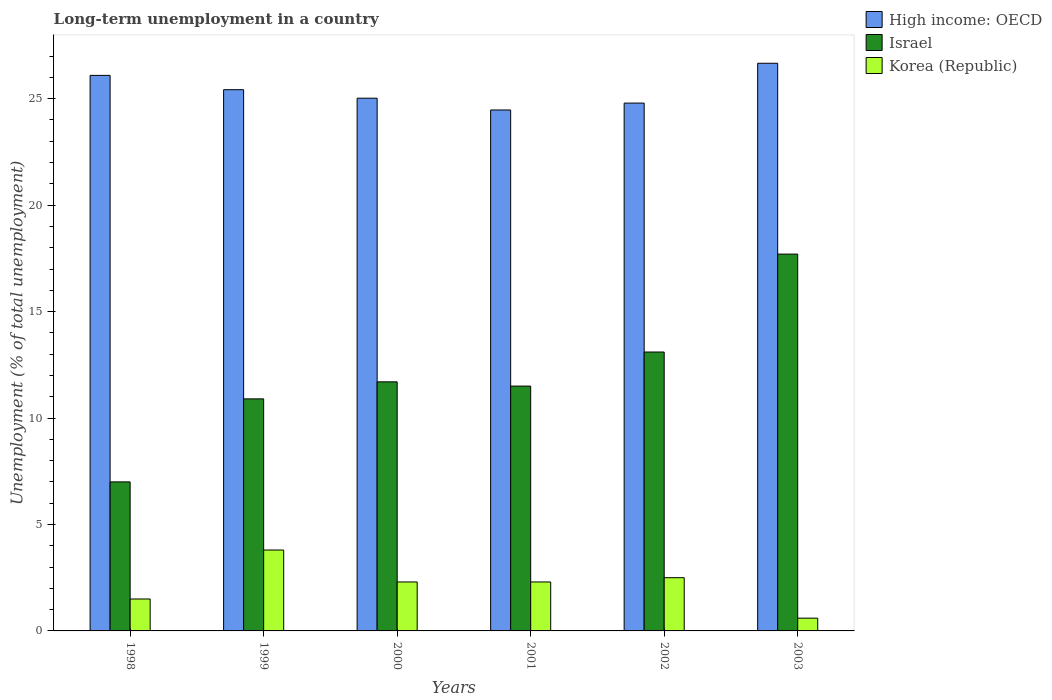How many different coloured bars are there?
Make the answer very short. 3. Are the number of bars on each tick of the X-axis equal?
Offer a terse response. Yes. How many bars are there on the 2nd tick from the left?
Offer a very short reply. 3. How many bars are there on the 6th tick from the right?
Give a very brief answer. 3. What is the label of the 2nd group of bars from the left?
Provide a succinct answer. 1999. In how many cases, is the number of bars for a given year not equal to the number of legend labels?
Make the answer very short. 0. What is the percentage of long-term unemployed population in Israel in 2000?
Ensure brevity in your answer.  11.7. Across all years, what is the maximum percentage of long-term unemployed population in Israel?
Your answer should be compact. 17.7. Across all years, what is the minimum percentage of long-term unemployed population in High income: OECD?
Offer a terse response. 24.47. In which year was the percentage of long-term unemployed population in Israel maximum?
Keep it short and to the point. 2003. In which year was the percentage of long-term unemployed population in Israel minimum?
Keep it short and to the point. 1998. What is the total percentage of long-term unemployed population in High income: OECD in the graph?
Keep it short and to the point. 152.47. What is the difference between the percentage of long-term unemployed population in High income: OECD in 1999 and that in 2000?
Offer a very short reply. 0.4. What is the difference between the percentage of long-term unemployed population in High income: OECD in 1998 and the percentage of long-term unemployed population in Korea (Republic) in 2001?
Give a very brief answer. 23.79. What is the average percentage of long-term unemployed population in Israel per year?
Offer a very short reply. 11.98. In the year 2002, what is the difference between the percentage of long-term unemployed population in Korea (Republic) and percentage of long-term unemployed population in High income: OECD?
Your answer should be very brief. -22.29. What is the ratio of the percentage of long-term unemployed population in Korea (Republic) in 1999 to that in 2003?
Your response must be concise. 6.33. Is the percentage of long-term unemployed population in Israel in 1998 less than that in 2000?
Give a very brief answer. Yes. What is the difference between the highest and the second highest percentage of long-term unemployed population in High income: OECD?
Your answer should be very brief. 0.57. What is the difference between the highest and the lowest percentage of long-term unemployed population in Korea (Republic)?
Give a very brief answer. 3.2. In how many years, is the percentage of long-term unemployed population in Korea (Republic) greater than the average percentage of long-term unemployed population in Korea (Republic) taken over all years?
Offer a very short reply. 4. What does the 2nd bar from the left in 2002 represents?
Offer a very short reply. Israel. What does the 3rd bar from the right in 2003 represents?
Keep it short and to the point. High income: OECD. How many bars are there?
Give a very brief answer. 18. Are all the bars in the graph horizontal?
Ensure brevity in your answer.  No. What is the difference between two consecutive major ticks on the Y-axis?
Make the answer very short. 5. Does the graph contain any zero values?
Your answer should be compact. No. Where does the legend appear in the graph?
Your answer should be very brief. Top right. How many legend labels are there?
Provide a succinct answer. 3. What is the title of the graph?
Keep it short and to the point. Long-term unemployment in a country. Does "Germany" appear as one of the legend labels in the graph?
Your answer should be compact. No. What is the label or title of the Y-axis?
Give a very brief answer. Unemployment (% of total unemployment). What is the Unemployment (% of total unemployment) of High income: OECD in 1998?
Give a very brief answer. 26.09. What is the Unemployment (% of total unemployment) in High income: OECD in 1999?
Ensure brevity in your answer.  25.42. What is the Unemployment (% of total unemployment) in Israel in 1999?
Offer a very short reply. 10.9. What is the Unemployment (% of total unemployment) in Korea (Republic) in 1999?
Make the answer very short. 3.8. What is the Unemployment (% of total unemployment) of High income: OECD in 2000?
Offer a terse response. 25.02. What is the Unemployment (% of total unemployment) of Israel in 2000?
Your answer should be compact. 11.7. What is the Unemployment (% of total unemployment) in Korea (Republic) in 2000?
Provide a succinct answer. 2.3. What is the Unemployment (% of total unemployment) of High income: OECD in 2001?
Keep it short and to the point. 24.47. What is the Unemployment (% of total unemployment) in Korea (Republic) in 2001?
Keep it short and to the point. 2.3. What is the Unemployment (% of total unemployment) in High income: OECD in 2002?
Offer a terse response. 24.79. What is the Unemployment (% of total unemployment) of Israel in 2002?
Your response must be concise. 13.1. What is the Unemployment (% of total unemployment) of Korea (Republic) in 2002?
Provide a succinct answer. 2.5. What is the Unemployment (% of total unemployment) of High income: OECD in 2003?
Your answer should be very brief. 26.66. What is the Unemployment (% of total unemployment) of Israel in 2003?
Provide a succinct answer. 17.7. What is the Unemployment (% of total unemployment) in Korea (Republic) in 2003?
Ensure brevity in your answer.  0.6. Across all years, what is the maximum Unemployment (% of total unemployment) of High income: OECD?
Your answer should be compact. 26.66. Across all years, what is the maximum Unemployment (% of total unemployment) of Israel?
Provide a succinct answer. 17.7. Across all years, what is the maximum Unemployment (% of total unemployment) in Korea (Republic)?
Make the answer very short. 3.8. Across all years, what is the minimum Unemployment (% of total unemployment) of High income: OECD?
Provide a short and direct response. 24.47. Across all years, what is the minimum Unemployment (% of total unemployment) in Israel?
Make the answer very short. 7. Across all years, what is the minimum Unemployment (% of total unemployment) in Korea (Republic)?
Your answer should be compact. 0.6. What is the total Unemployment (% of total unemployment) of High income: OECD in the graph?
Give a very brief answer. 152.47. What is the total Unemployment (% of total unemployment) in Israel in the graph?
Provide a succinct answer. 71.9. What is the total Unemployment (% of total unemployment) in Korea (Republic) in the graph?
Make the answer very short. 13. What is the difference between the Unemployment (% of total unemployment) in High income: OECD in 1998 and that in 1999?
Keep it short and to the point. 0.67. What is the difference between the Unemployment (% of total unemployment) in Israel in 1998 and that in 1999?
Provide a short and direct response. -3.9. What is the difference between the Unemployment (% of total unemployment) of Korea (Republic) in 1998 and that in 1999?
Offer a very short reply. -2.3. What is the difference between the Unemployment (% of total unemployment) in High income: OECD in 1998 and that in 2000?
Provide a short and direct response. 1.07. What is the difference between the Unemployment (% of total unemployment) of Korea (Republic) in 1998 and that in 2000?
Provide a succinct answer. -0.8. What is the difference between the Unemployment (% of total unemployment) in High income: OECD in 1998 and that in 2001?
Offer a very short reply. 1.63. What is the difference between the Unemployment (% of total unemployment) of Israel in 1998 and that in 2001?
Offer a terse response. -4.5. What is the difference between the Unemployment (% of total unemployment) of Korea (Republic) in 1998 and that in 2001?
Keep it short and to the point. -0.8. What is the difference between the Unemployment (% of total unemployment) of High income: OECD in 1998 and that in 2002?
Your answer should be compact. 1.3. What is the difference between the Unemployment (% of total unemployment) of Korea (Republic) in 1998 and that in 2002?
Give a very brief answer. -1. What is the difference between the Unemployment (% of total unemployment) of High income: OECD in 1998 and that in 2003?
Your answer should be compact. -0.57. What is the difference between the Unemployment (% of total unemployment) in High income: OECD in 1999 and that in 2000?
Your answer should be compact. 0.4. What is the difference between the Unemployment (% of total unemployment) of Korea (Republic) in 1999 and that in 2000?
Provide a succinct answer. 1.5. What is the difference between the Unemployment (% of total unemployment) of High income: OECD in 1999 and that in 2001?
Give a very brief answer. 0.95. What is the difference between the Unemployment (% of total unemployment) in Israel in 1999 and that in 2001?
Provide a short and direct response. -0.6. What is the difference between the Unemployment (% of total unemployment) of High income: OECD in 1999 and that in 2002?
Your answer should be compact. 0.63. What is the difference between the Unemployment (% of total unemployment) of High income: OECD in 1999 and that in 2003?
Your answer should be very brief. -1.24. What is the difference between the Unemployment (% of total unemployment) of Israel in 1999 and that in 2003?
Your answer should be compact. -6.8. What is the difference between the Unemployment (% of total unemployment) in Korea (Republic) in 1999 and that in 2003?
Your response must be concise. 3.2. What is the difference between the Unemployment (% of total unemployment) in High income: OECD in 2000 and that in 2001?
Provide a short and direct response. 0.55. What is the difference between the Unemployment (% of total unemployment) in Israel in 2000 and that in 2001?
Provide a short and direct response. 0.2. What is the difference between the Unemployment (% of total unemployment) of High income: OECD in 2000 and that in 2002?
Your answer should be compact. 0.23. What is the difference between the Unemployment (% of total unemployment) of Korea (Republic) in 2000 and that in 2002?
Keep it short and to the point. -0.2. What is the difference between the Unemployment (% of total unemployment) of High income: OECD in 2000 and that in 2003?
Your response must be concise. -1.64. What is the difference between the Unemployment (% of total unemployment) in High income: OECD in 2001 and that in 2002?
Your response must be concise. -0.32. What is the difference between the Unemployment (% of total unemployment) in Korea (Republic) in 2001 and that in 2002?
Provide a succinct answer. -0.2. What is the difference between the Unemployment (% of total unemployment) in High income: OECD in 2001 and that in 2003?
Ensure brevity in your answer.  -2.19. What is the difference between the Unemployment (% of total unemployment) in Israel in 2001 and that in 2003?
Provide a short and direct response. -6.2. What is the difference between the Unemployment (% of total unemployment) of High income: OECD in 2002 and that in 2003?
Your answer should be very brief. -1.87. What is the difference between the Unemployment (% of total unemployment) in Israel in 2002 and that in 2003?
Provide a succinct answer. -4.6. What is the difference between the Unemployment (% of total unemployment) of Korea (Republic) in 2002 and that in 2003?
Make the answer very short. 1.9. What is the difference between the Unemployment (% of total unemployment) in High income: OECD in 1998 and the Unemployment (% of total unemployment) in Israel in 1999?
Your response must be concise. 15.19. What is the difference between the Unemployment (% of total unemployment) of High income: OECD in 1998 and the Unemployment (% of total unemployment) of Korea (Republic) in 1999?
Offer a terse response. 22.29. What is the difference between the Unemployment (% of total unemployment) in Israel in 1998 and the Unemployment (% of total unemployment) in Korea (Republic) in 1999?
Provide a succinct answer. 3.2. What is the difference between the Unemployment (% of total unemployment) in High income: OECD in 1998 and the Unemployment (% of total unemployment) in Israel in 2000?
Provide a succinct answer. 14.39. What is the difference between the Unemployment (% of total unemployment) of High income: OECD in 1998 and the Unemployment (% of total unemployment) of Korea (Republic) in 2000?
Your answer should be very brief. 23.79. What is the difference between the Unemployment (% of total unemployment) of Israel in 1998 and the Unemployment (% of total unemployment) of Korea (Republic) in 2000?
Provide a succinct answer. 4.7. What is the difference between the Unemployment (% of total unemployment) of High income: OECD in 1998 and the Unemployment (% of total unemployment) of Israel in 2001?
Keep it short and to the point. 14.59. What is the difference between the Unemployment (% of total unemployment) of High income: OECD in 1998 and the Unemployment (% of total unemployment) of Korea (Republic) in 2001?
Offer a terse response. 23.79. What is the difference between the Unemployment (% of total unemployment) in High income: OECD in 1998 and the Unemployment (% of total unemployment) in Israel in 2002?
Keep it short and to the point. 12.99. What is the difference between the Unemployment (% of total unemployment) in High income: OECD in 1998 and the Unemployment (% of total unemployment) in Korea (Republic) in 2002?
Your answer should be very brief. 23.59. What is the difference between the Unemployment (% of total unemployment) in Israel in 1998 and the Unemployment (% of total unemployment) in Korea (Republic) in 2002?
Provide a short and direct response. 4.5. What is the difference between the Unemployment (% of total unemployment) in High income: OECD in 1998 and the Unemployment (% of total unemployment) in Israel in 2003?
Your answer should be very brief. 8.39. What is the difference between the Unemployment (% of total unemployment) of High income: OECD in 1998 and the Unemployment (% of total unemployment) of Korea (Republic) in 2003?
Provide a short and direct response. 25.49. What is the difference between the Unemployment (% of total unemployment) of Israel in 1998 and the Unemployment (% of total unemployment) of Korea (Republic) in 2003?
Your answer should be very brief. 6.4. What is the difference between the Unemployment (% of total unemployment) of High income: OECD in 1999 and the Unemployment (% of total unemployment) of Israel in 2000?
Ensure brevity in your answer.  13.72. What is the difference between the Unemployment (% of total unemployment) in High income: OECD in 1999 and the Unemployment (% of total unemployment) in Korea (Republic) in 2000?
Provide a short and direct response. 23.12. What is the difference between the Unemployment (% of total unemployment) in High income: OECD in 1999 and the Unemployment (% of total unemployment) in Israel in 2001?
Your answer should be compact. 13.92. What is the difference between the Unemployment (% of total unemployment) of High income: OECD in 1999 and the Unemployment (% of total unemployment) of Korea (Republic) in 2001?
Provide a short and direct response. 23.12. What is the difference between the Unemployment (% of total unemployment) in Israel in 1999 and the Unemployment (% of total unemployment) in Korea (Republic) in 2001?
Your answer should be compact. 8.6. What is the difference between the Unemployment (% of total unemployment) of High income: OECD in 1999 and the Unemployment (% of total unemployment) of Israel in 2002?
Give a very brief answer. 12.32. What is the difference between the Unemployment (% of total unemployment) of High income: OECD in 1999 and the Unemployment (% of total unemployment) of Korea (Republic) in 2002?
Keep it short and to the point. 22.92. What is the difference between the Unemployment (% of total unemployment) in High income: OECD in 1999 and the Unemployment (% of total unemployment) in Israel in 2003?
Your answer should be compact. 7.72. What is the difference between the Unemployment (% of total unemployment) of High income: OECD in 1999 and the Unemployment (% of total unemployment) of Korea (Republic) in 2003?
Ensure brevity in your answer.  24.82. What is the difference between the Unemployment (% of total unemployment) in Israel in 1999 and the Unemployment (% of total unemployment) in Korea (Republic) in 2003?
Provide a succinct answer. 10.3. What is the difference between the Unemployment (% of total unemployment) of High income: OECD in 2000 and the Unemployment (% of total unemployment) of Israel in 2001?
Provide a succinct answer. 13.52. What is the difference between the Unemployment (% of total unemployment) in High income: OECD in 2000 and the Unemployment (% of total unemployment) in Korea (Republic) in 2001?
Provide a short and direct response. 22.72. What is the difference between the Unemployment (% of total unemployment) of Israel in 2000 and the Unemployment (% of total unemployment) of Korea (Republic) in 2001?
Offer a very short reply. 9.4. What is the difference between the Unemployment (% of total unemployment) of High income: OECD in 2000 and the Unemployment (% of total unemployment) of Israel in 2002?
Make the answer very short. 11.92. What is the difference between the Unemployment (% of total unemployment) in High income: OECD in 2000 and the Unemployment (% of total unemployment) in Korea (Republic) in 2002?
Keep it short and to the point. 22.52. What is the difference between the Unemployment (% of total unemployment) in High income: OECD in 2000 and the Unemployment (% of total unemployment) in Israel in 2003?
Provide a succinct answer. 7.32. What is the difference between the Unemployment (% of total unemployment) of High income: OECD in 2000 and the Unemployment (% of total unemployment) of Korea (Republic) in 2003?
Your response must be concise. 24.42. What is the difference between the Unemployment (% of total unemployment) in High income: OECD in 2001 and the Unemployment (% of total unemployment) in Israel in 2002?
Offer a terse response. 11.37. What is the difference between the Unemployment (% of total unemployment) in High income: OECD in 2001 and the Unemployment (% of total unemployment) in Korea (Republic) in 2002?
Offer a very short reply. 21.97. What is the difference between the Unemployment (% of total unemployment) of Israel in 2001 and the Unemployment (% of total unemployment) of Korea (Republic) in 2002?
Offer a very short reply. 9. What is the difference between the Unemployment (% of total unemployment) of High income: OECD in 2001 and the Unemployment (% of total unemployment) of Israel in 2003?
Your answer should be compact. 6.77. What is the difference between the Unemployment (% of total unemployment) of High income: OECD in 2001 and the Unemployment (% of total unemployment) of Korea (Republic) in 2003?
Your answer should be very brief. 23.87. What is the difference between the Unemployment (% of total unemployment) of High income: OECD in 2002 and the Unemployment (% of total unemployment) of Israel in 2003?
Ensure brevity in your answer.  7.09. What is the difference between the Unemployment (% of total unemployment) of High income: OECD in 2002 and the Unemployment (% of total unemployment) of Korea (Republic) in 2003?
Provide a short and direct response. 24.19. What is the average Unemployment (% of total unemployment) of High income: OECD per year?
Offer a very short reply. 25.41. What is the average Unemployment (% of total unemployment) of Israel per year?
Ensure brevity in your answer.  11.98. What is the average Unemployment (% of total unemployment) in Korea (Republic) per year?
Offer a terse response. 2.17. In the year 1998, what is the difference between the Unemployment (% of total unemployment) of High income: OECD and Unemployment (% of total unemployment) of Israel?
Provide a succinct answer. 19.09. In the year 1998, what is the difference between the Unemployment (% of total unemployment) in High income: OECD and Unemployment (% of total unemployment) in Korea (Republic)?
Give a very brief answer. 24.59. In the year 1999, what is the difference between the Unemployment (% of total unemployment) in High income: OECD and Unemployment (% of total unemployment) in Israel?
Provide a short and direct response. 14.52. In the year 1999, what is the difference between the Unemployment (% of total unemployment) of High income: OECD and Unemployment (% of total unemployment) of Korea (Republic)?
Offer a very short reply. 21.62. In the year 2000, what is the difference between the Unemployment (% of total unemployment) of High income: OECD and Unemployment (% of total unemployment) of Israel?
Provide a short and direct response. 13.32. In the year 2000, what is the difference between the Unemployment (% of total unemployment) of High income: OECD and Unemployment (% of total unemployment) of Korea (Republic)?
Provide a short and direct response. 22.72. In the year 2000, what is the difference between the Unemployment (% of total unemployment) in Israel and Unemployment (% of total unemployment) in Korea (Republic)?
Offer a very short reply. 9.4. In the year 2001, what is the difference between the Unemployment (% of total unemployment) of High income: OECD and Unemployment (% of total unemployment) of Israel?
Keep it short and to the point. 12.97. In the year 2001, what is the difference between the Unemployment (% of total unemployment) in High income: OECD and Unemployment (% of total unemployment) in Korea (Republic)?
Provide a succinct answer. 22.17. In the year 2002, what is the difference between the Unemployment (% of total unemployment) in High income: OECD and Unemployment (% of total unemployment) in Israel?
Provide a succinct answer. 11.69. In the year 2002, what is the difference between the Unemployment (% of total unemployment) of High income: OECD and Unemployment (% of total unemployment) of Korea (Republic)?
Your answer should be very brief. 22.29. In the year 2003, what is the difference between the Unemployment (% of total unemployment) of High income: OECD and Unemployment (% of total unemployment) of Israel?
Your response must be concise. 8.96. In the year 2003, what is the difference between the Unemployment (% of total unemployment) in High income: OECD and Unemployment (% of total unemployment) in Korea (Republic)?
Keep it short and to the point. 26.06. What is the ratio of the Unemployment (% of total unemployment) in High income: OECD in 1998 to that in 1999?
Make the answer very short. 1.03. What is the ratio of the Unemployment (% of total unemployment) of Israel in 1998 to that in 1999?
Ensure brevity in your answer.  0.64. What is the ratio of the Unemployment (% of total unemployment) of Korea (Republic) in 1998 to that in 1999?
Offer a very short reply. 0.39. What is the ratio of the Unemployment (% of total unemployment) in High income: OECD in 1998 to that in 2000?
Make the answer very short. 1.04. What is the ratio of the Unemployment (% of total unemployment) in Israel in 1998 to that in 2000?
Your answer should be very brief. 0.6. What is the ratio of the Unemployment (% of total unemployment) in Korea (Republic) in 1998 to that in 2000?
Offer a terse response. 0.65. What is the ratio of the Unemployment (% of total unemployment) in High income: OECD in 1998 to that in 2001?
Keep it short and to the point. 1.07. What is the ratio of the Unemployment (% of total unemployment) of Israel in 1998 to that in 2001?
Your answer should be compact. 0.61. What is the ratio of the Unemployment (% of total unemployment) of Korea (Republic) in 1998 to that in 2001?
Your answer should be very brief. 0.65. What is the ratio of the Unemployment (% of total unemployment) in High income: OECD in 1998 to that in 2002?
Make the answer very short. 1.05. What is the ratio of the Unemployment (% of total unemployment) of Israel in 1998 to that in 2002?
Make the answer very short. 0.53. What is the ratio of the Unemployment (% of total unemployment) in High income: OECD in 1998 to that in 2003?
Give a very brief answer. 0.98. What is the ratio of the Unemployment (% of total unemployment) of Israel in 1998 to that in 2003?
Your answer should be very brief. 0.4. What is the ratio of the Unemployment (% of total unemployment) of High income: OECD in 1999 to that in 2000?
Your answer should be very brief. 1.02. What is the ratio of the Unemployment (% of total unemployment) in Israel in 1999 to that in 2000?
Ensure brevity in your answer.  0.93. What is the ratio of the Unemployment (% of total unemployment) in Korea (Republic) in 1999 to that in 2000?
Make the answer very short. 1.65. What is the ratio of the Unemployment (% of total unemployment) of High income: OECD in 1999 to that in 2001?
Ensure brevity in your answer.  1.04. What is the ratio of the Unemployment (% of total unemployment) in Israel in 1999 to that in 2001?
Keep it short and to the point. 0.95. What is the ratio of the Unemployment (% of total unemployment) of Korea (Republic) in 1999 to that in 2001?
Your answer should be very brief. 1.65. What is the ratio of the Unemployment (% of total unemployment) of High income: OECD in 1999 to that in 2002?
Give a very brief answer. 1.03. What is the ratio of the Unemployment (% of total unemployment) in Israel in 1999 to that in 2002?
Keep it short and to the point. 0.83. What is the ratio of the Unemployment (% of total unemployment) in Korea (Republic) in 1999 to that in 2002?
Give a very brief answer. 1.52. What is the ratio of the Unemployment (% of total unemployment) in High income: OECD in 1999 to that in 2003?
Your answer should be very brief. 0.95. What is the ratio of the Unemployment (% of total unemployment) in Israel in 1999 to that in 2003?
Your answer should be very brief. 0.62. What is the ratio of the Unemployment (% of total unemployment) in Korea (Republic) in 1999 to that in 2003?
Keep it short and to the point. 6.33. What is the ratio of the Unemployment (% of total unemployment) of High income: OECD in 2000 to that in 2001?
Your answer should be compact. 1.02. What is the ratio of the Unemployment (% of total unemployment) of Israel in 2000 to that in 2001?
Your answer should be compact. 1.02. What is the ratio of the Unemployment (% of total unemployment) in Korea (Republic) in 2000 to that in 2001?
Your answer should be compact. 1. What is the ratio of the Unemployment (% of total unemployment) of High income: OECD in 2000 to that in 2002?
Make the answer very short. 1.01. What is the ratio of the Unemployment (% of total unemployment) in Israel in 2000 to that in 2002?
Your answer should be compact. 0.89. What is the ratio of the Unemployment (% of total unemployment) of High income: OECD in 2000 to that in 2003?
Provide a succinct answer. 0.94. What is the ratio of the Unemployment (% of total unemployment) of Israel in 2000 to that in 2003?
Offer a terse response. 0.66. What is the ratio of the Unemployment (% of total unemployment) in Korea (Republic) in 2000 to that in 2003?
Offer a terse response. 3.83. What is the ratio of the Unemployment (% of total unemployment) in High income: OECD in 2001 to that in 2002?
Keep it short and to the point. 0.99. What is the ratio of the Unemployment (% of total unemployment) in Israel in 2001 to that in 2002?
Provide a short and direct response. 0.88. What is the ratio of the Unemployment (% of total unemployment) of High income: OECD in 2001 to that in 2003?
Give a very brief answer. 0.92. What is the ratio of the Unemployment (% of total unemployment) in Israel in 2001 to that in 2003?
Keep it short and to the point. 0.65. What is the ratio of the Unemployment (% of total unemployment) of Korea (Republic) in 2001 to that in 2003?
Offer a terse response. 3.83. What is the ratio of the Unemployment (% of total unemployment) in High income: OECD in 2002 to that in 2003?
Provide a short and direct response. 0.93. What is the ratio of the Unemployment (% of total unemployment) of Israel in 2002 to that in 2003?
Your answer should be very brief. 0.74. What is the ratio of the Unemployment (% of total unemployment) in Korea (Republic) in 2002 to that in 2003?
Make the answer very short. 4.17. What is the difference between the highest and the second highest Unemployment (% of total unemployment) in High income: OECD?
Make the answer very short. 0.57. What is the difference between the highest and the second highest Unemployment (% of total unemployment) of Israel?
Your response must be concise. 4.6. What is the difference between the highest and the second highest Unemployment (% of total unemployment) of Korea (Republic)?
Provide a succinct answer. 1.3. What is the difference between the highest and the lowest Unemployment (% of total unemployment) in High income: OECD?
Your response must be concise. 2.19. 